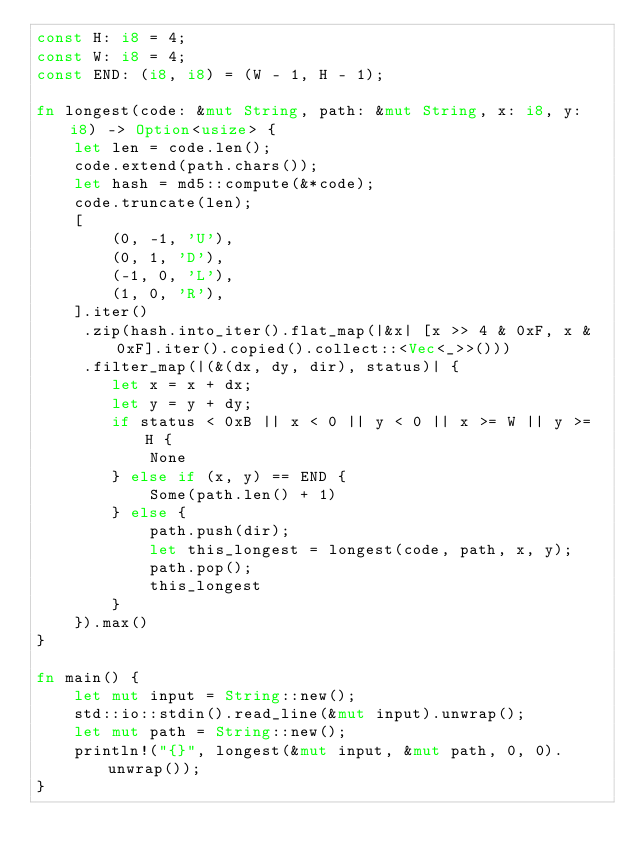<code> <loc_0><loc_0><loc_500><loc_500><_Rust_>const H: i8 = 4;
const W: i8 = 4;
const END: (i8, i8) = (W - 1, H - 1);

fn longest(code: &mut String, path: &mut String, x: i8, y: i8) -> Option<usize> {
    let len = code.len();
    code.extend(path.chars());
    let hash = md5::compute(&*code);
    code.truncate(len);
    [
        (0, -1, 'U'),
        (0, 1, 'D'),
        (-1, 0, 'L'),
        (1, 0, 'R'),
    ].iter()
     .zip(hash.into_iter().flat_map(|&x| [x >> 4 & 0xF, x & 0xF].iter().copied().collect::<Vec<_>>()))
     .filter_map(|(&(dx, dy, dir), status)| {
        let x = x + dx;
        let y = y + dy;
        if status < 0xB || x < 0 || y < 0 || x >= W || y >= H {
            None
        } else if (x, y) == END {
            Some(path.len() + 1)
        } else {
            path.push(dir);
            let this_longest = longest(code, path, x, y);
            path.pop();
            this_longest
        }
    }).max()
}

fn main() {
    let mut input = String::new();
    std::io::stdin().read_line(&mut input).unwrap();
    let mut path = String::new();
    println!("{}", longest(&mut input, &mut path, 0, 0).unwrap());
}
</code> 